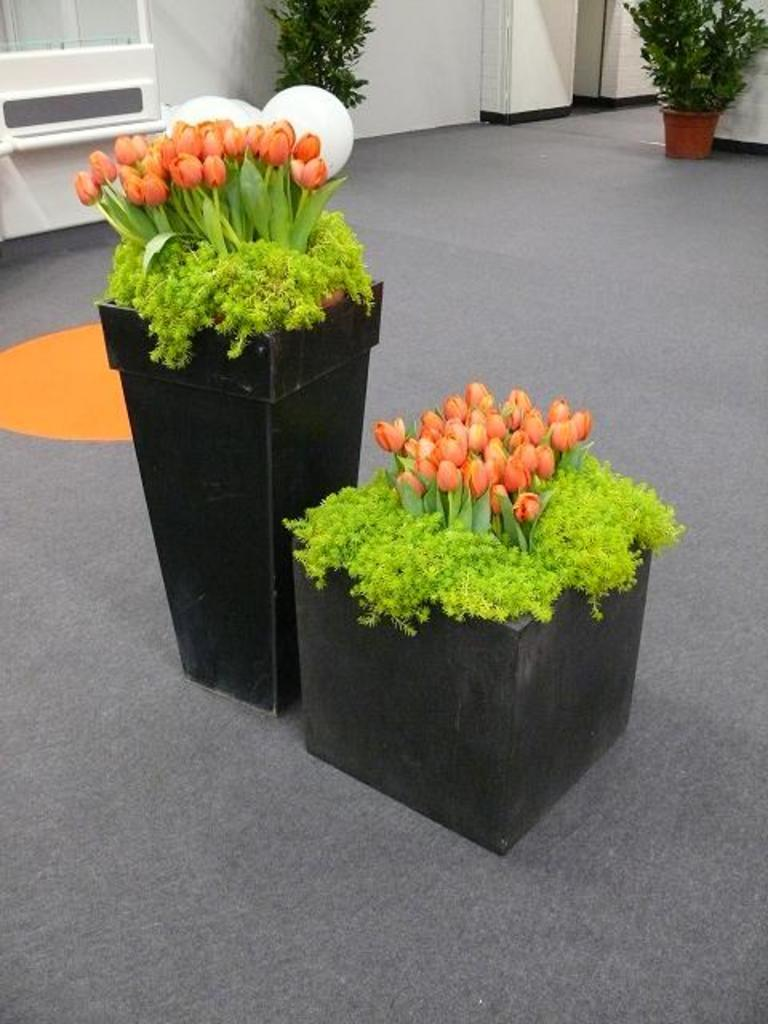What is the main subject of the image? The main subject of the image is flower pots. Where are the flower pots located in the image? There are flower pots in the center of the image and other plant pots at the top side of the image. What type of trail can be seen in the image? There is no trail present in the image; it features flower pots and plant pots. Can you tell me how many pencils are visible in the image? There are no pencils present in the image. 